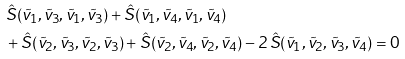<formula> <loc_0><loc_0><loc_500><loc_500>& \hat { S } ( \tilde { v } _ { 1 } , \tilde { v } _ { 3 } , \tilde { v } _ { 1 } , \tilde { v } _ { 3 } ) + \hat { S } ( \tilde { v } _ { 1 } , \tilde { v } _ { 4 } , \tilde { v } _ { 1 } , \tilde { v } _ { 4 } ) \\ & + \hat { S } ( \tilde { v } _ { 2 } , \tilde { v } _ { 3 } , \tilde { v } _ { 2 } , \tilde { v } _ { 3 } ) + \hat { S } ( \tilde { v } _ { 2 } , \tilde { v } _ { 4 } , \tilde { v } _ { 2 } , \tilde { v } _ { 4 } ) - 2 \, \hat { S } ( \tilde { v } _ { 1 } , \tilde { v } _ { 2 } , \tilde { v } _ { 3 } , \tilde { v } _ { 4 } ) = 0</formula> 